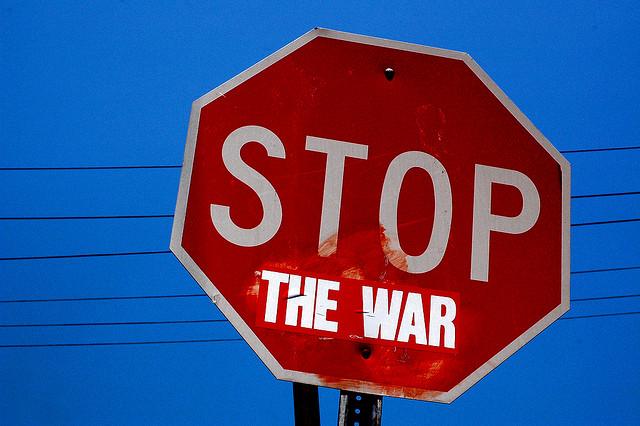Is this an intersection?
Short answer required. Yes. How many electrical lines are behind the sign?
Be succinct. 6. What should the sign say?
Quick response, please. Stop. What is behind the sign?
Be succinct. Sky. Was this photo taken during the daytime?
Quick response, please. Yes. What type of traffic sign is this?
Keep it brief. Stop. What shape is the sign?
Write a very short answer. Octagon. 